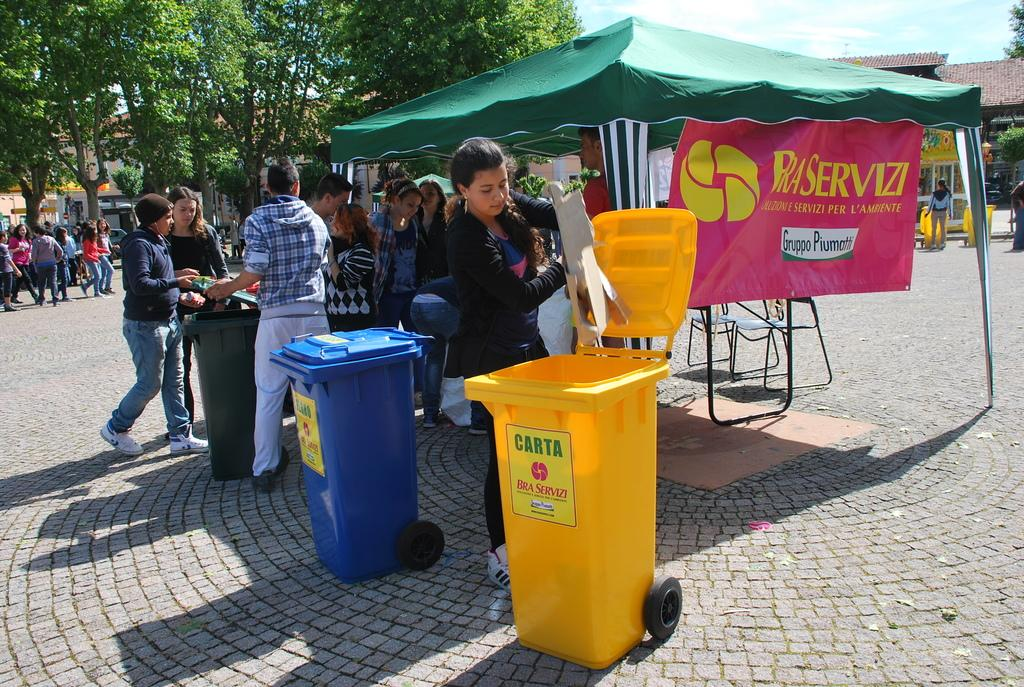<image>
Give a short and clear explanation of the subsequent image. a girl throwing things into a yellow can labeled 'carta bra servizi' 